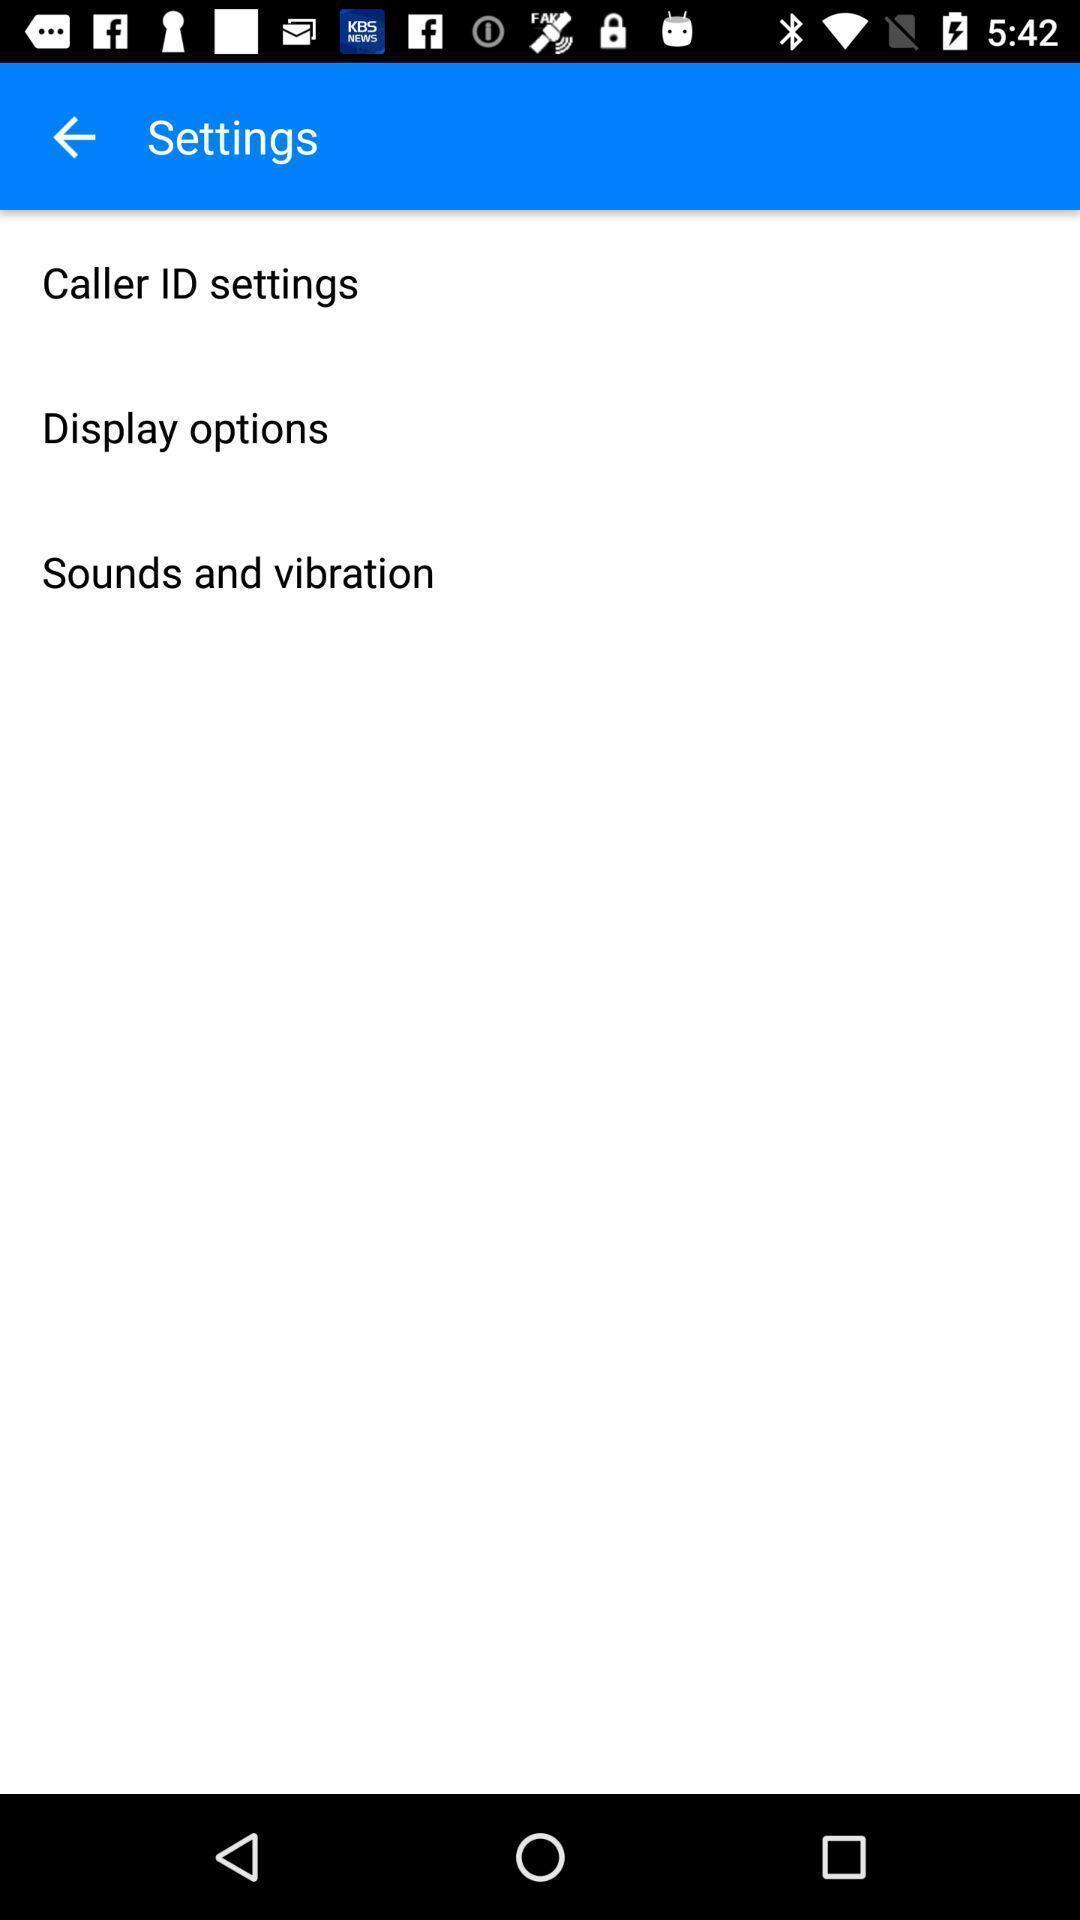Provide a textual representation of this image. Settings page with different options the calling app. 